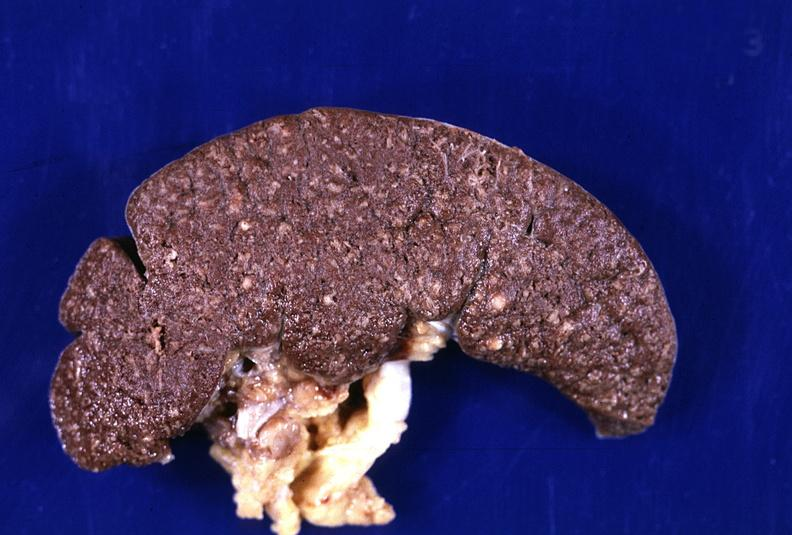what does this image show?
Answer the question using a single word or phrase. Spleen 